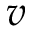Convert formula to latex. <formula><loc_0><loc_0><loc_500><loc_500>v</formula> 